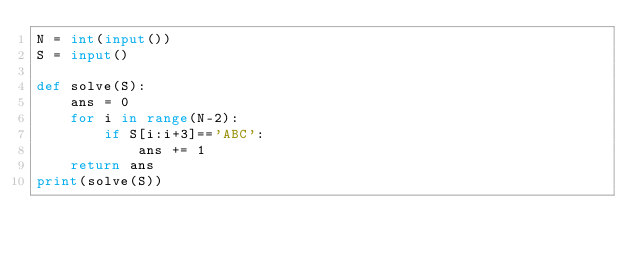<code> <loc_0><loc_0><loc_500><loc_500><_Python_>N = int(input())
S = input()

def solve(S):
    ans = 0
    for i in range(N-2):
        if S[i:i+3]=='ABC':
            ans += 1
    return ans
print(solve(S))</code> 